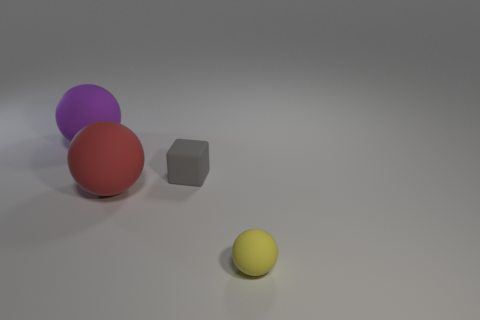Is there any other thing that has the same shape as the small gray thing?
Make the answer very short. No. There is a red sphere that is to the right of the big matte thing behind the cube; how big is it?
Your answer should be very brief. Large. What color is the object that is right of the large red matte ball and left of the yellow object?
Your answer should be compact. Gray. What material is the sphere that is the same size as the block?
Ensure brevity in your answer.  Rubber. What number of other things are the same material as the purple ball?
Make the answer very short. 3. There is a large object in front of the small matte cube; is it the same color as the object that is in front of the red rubber sphere?
Your response must be concise. No. What shape is the small rubber object in front of the tiny thing to the left of the tiny yellow matte ball?
Offer a terse response. Sphere. How many other things are there of the same color as the cube?
Offer a terse response. 0. Does the ball that is to the left of the red sphere have the same material as the large object in front of the block?
Ensure brevity in your answer.  Yes. There is a cube on the right side of the large purple object; how big is it?
Offer a very short reply. Small. 